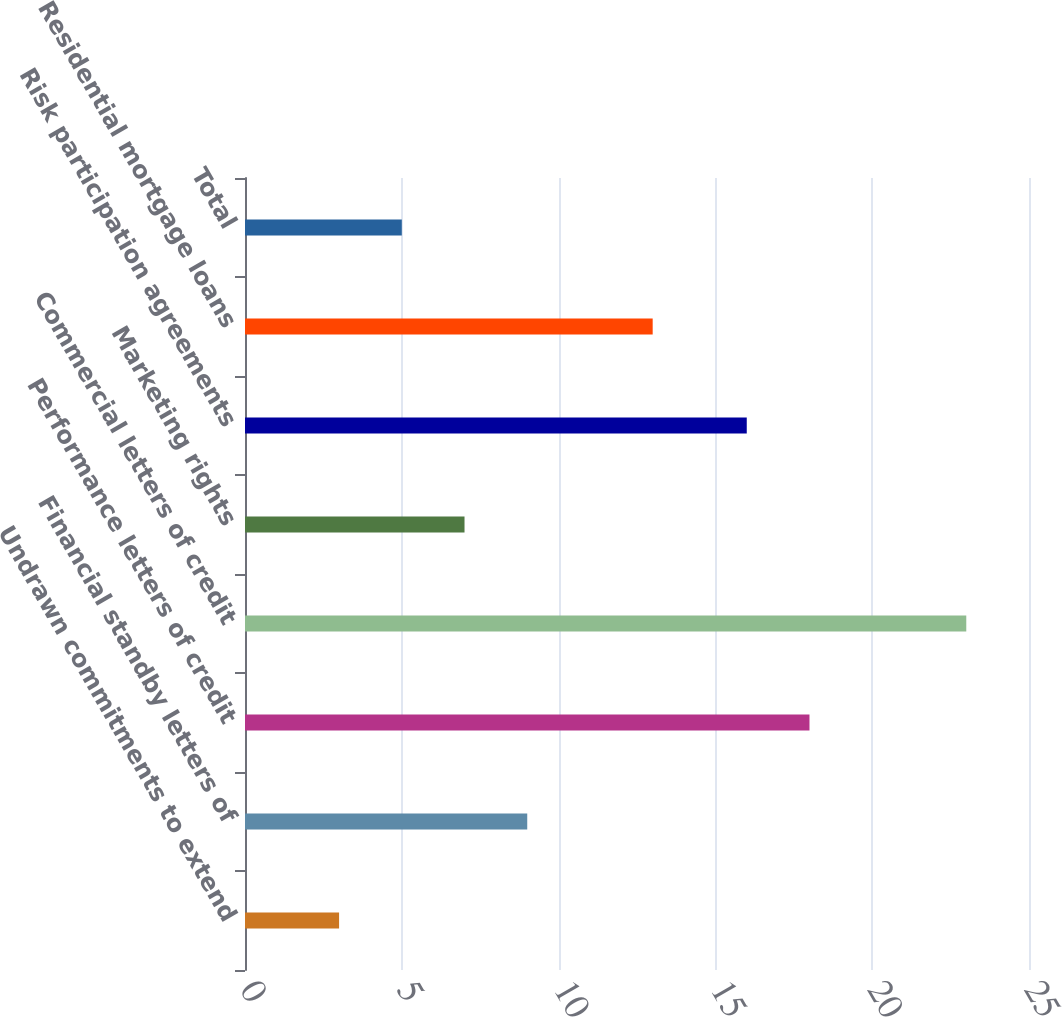<chart> <loc_0><loc_0><loc_500><loc_500><bar_chart><fcel>Undrawn commitments to extend<fcel>Financial standby letters of<fcel>Performance letters of credit<fcel>Commercial letters of credit<fcel>Marketing rights<fcel>Risk participation agreements<fcel>Residential mortgage loans<fcel>Total<nl><fcel>3<fcel>9<fcel>18<fcel>23<fcel>7<fcel>16<fcel>13<fcel>5<nl></chart> 